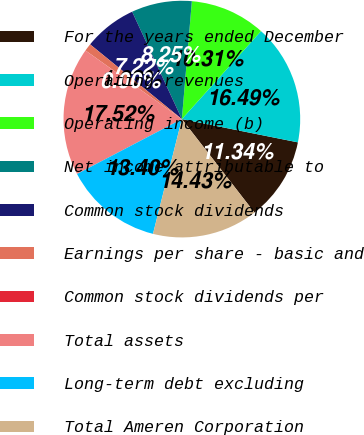Convert chart. <chart><loc_0><loc_0><loc_500><loc_500><pie_chart><fcel>For the years ended December<fcel>Operating revenues<fcel>Operating income (b)<fcel>Net income attributable to<fcel>Common stock dividends<fcel>Earnings per share - basic and<fcel>Common stock dividends per<fcel>Total assets<fcel>Long-term debt excluding<fcel>Total Ameren Corporation<nl><fcel>11.34%<fcel>16.49%<fcel>10.31%<fcel>8.25%<fcel>7.22%<fcel>1.03%<fcel>0.0%<fcel>17.52%<fcel>13.4%<fcel>14.43%<nl></chart> 